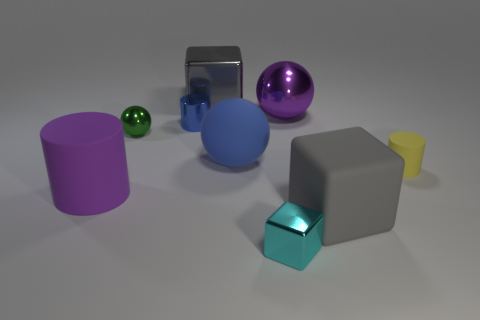What number of large blue rubber balls are there? 1 